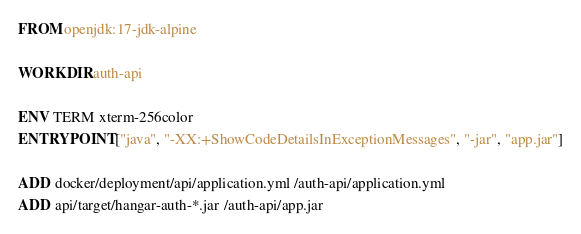Convert code to text. <code><loc_0><loc_0><loc_500><loc_500><_Dockerfile_>FROM openjdk:17-jdk-alpine

WORKDIR auth-api

ENV TERM xterm-256color
ENTRYPOINT ["java", "-XX:+ShowCodeDetailsInExceptionMessages", "-jar", "app.jar"]

ADD docker/deployment/api/application.yml /auth-api/application.yml
ADD api/target/hangar-auth-*.jar /auth-api/app.jar
</code> 